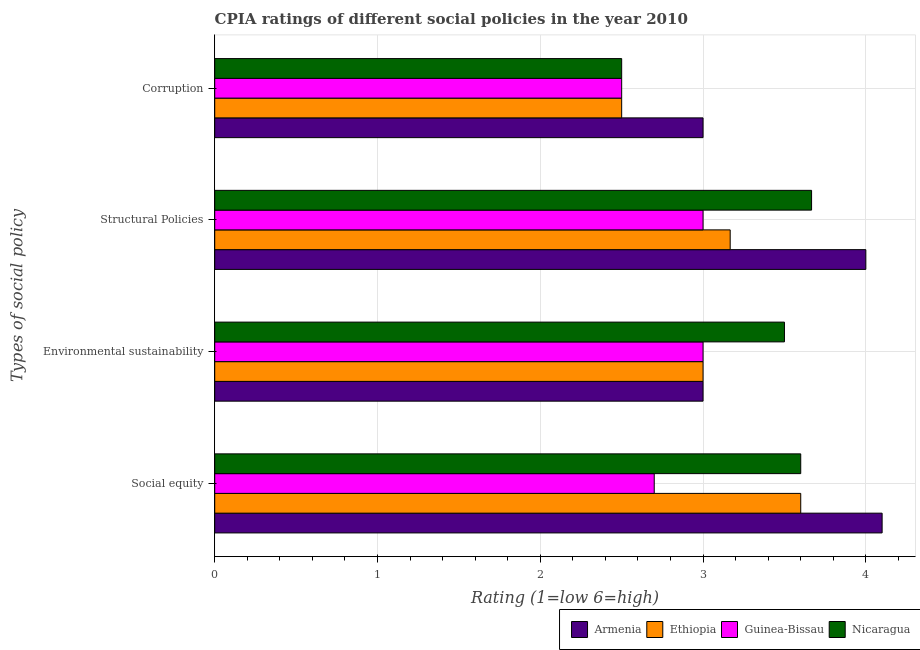Are the number of bars per tick equal to the number of legend labels?
Your answer should be very brief. Yes. Are the number of bars on each tick of the Y-axis equal?
Provide a succinct answer. Yes. How many bars are there on the 2nd tick from the bottom?
Your answer should be very brief. 4. What is the label of the 4th group of bars from the top?
Offer a very short reply. Social equity. In which country was the cpia rating of corruption maximum?
Your answer should be very brief. Armenia. In which country was the cpia rating of corruption minimum?
Provide a succinct answer. Ethiopia. What is the difference between the cpia rating of social equity in Guinea-Bissau and that in Armenia?
Provide a short and direct response. -1.4. What is the average cpia rating of environmental sustainability per country?
Keep it short and to the point. 3.12. What is the difference between the cpia rating of structural policies and cpia rating of environmental sustainability in Armenia?
Provide a short and direct response. 1. Is the cpia rating of corruption in Armenia less than that in Nicaragua?
Keep it short and to the point. No. Is the difference between the cpia rating of social equity in Guinea-Bissau and Ethiopia greater than the difference between the cpia rating of structural policies in Guinea-Bissau and Ethiopia?
Offer a terse response. No. What is the difference between the highest and the second highest cpia rating of social equity?
Your answer should be very brief. 0.5. What is the difference between the highest and the lowest cpia rating of environmental sustainability?
Your response must be concise. 0.5. Is it the case that in every country, the sum of the cpia rating of environmental sustainability and cpia rating of structural policies is greater than the sum of cpia rating of corruption and cpia rating of social equity?
Your response must be concise. No. What does the 1st bar from the top in Structural Policies represents?
Keep it short and to the point. Nicaragua. What does the 3rd bar from the bottom in Social equity represents?
Offer a terse response. Guinea-Bissau. How many bars are there?
Provide a succinct answer. 16. Are all the bars in the graph horizontal?
Provide a short and direct response. Yes. What is the difference between two consecutive major ticks on the X-axis?
Keep it short and to the point. 1. Where does the legend appear in the graph?
Offer a terse response. Bottom right. How many legend labels are there?
Your response must be concise. 4. What is the title of the graph?
Offer a very short reply. CPIA ratings of different social policies in the year 2010. What is the label or title of the X-axis?
Keep it short and to the point. Rating (1=low 6=high). What is the label or title of the Y-axis?
Provide a succinct answer. Types of social policy. What is the Rating (1=low 6=high) of Armenia in Social equity?
Provide a short and direct response. 4.1. What is the Rating (1=low 6=high) of Nicaragua in Social equity?
Ensure brevity in your answer.  3.6. What is the Rating (1=low 6=high) of Armenia in Environmental sustainability?
Provide a short and direct response. 3. What is the Rating (1=low 6=high) of Guinea-Bissau in Environmental sustainability?
Provide a short and direct response. 3. What is the Rating (1=low 6=high) of Nicaragua in Environmental sustainability?
Make the answer very short. 3.5. What is the Rating (1=low 6=high) in Armenia in Structural Policies?
Your answer should be compact. 4. What is the Rating (1=low 6=high) of Ethiopia in Structural Policies?
Provide a succinct answer. 3.17. What is the Rating (1=low 6=high) of Guinea-Bissau in Structural Policies?
Ensure brevity in your answer.  3. What is the Rating (1=low 6=high) of Nicaragua in Structural Policies?
Provide a short and direct response. 3.67. What is the Rating (1=low 6=high) of Armenia in Corruption?
Your answer should be very brief. 3. What is the Rating (1=low 6=high) of Ethiopia in Corruption?
Your answer should be very brief. 2.5. What is the Rating (1=low 6=high) of Nicaragua in Corruption?
Provide a succinct answer. 2.5. Across all Types of social policy, what is the maximum Rating (1=low 6=high) in Nicaragua?
Make the answer very short. 3.67. Across all Types of social policy, what is the minimum Rating (1=low 6=high) of Armenia?
Give a very brief answer. 3. Across all Types of social policy, what is the minimum Rating (1=low 6=high) of Ethiopia?
Your response must be concise. 2.5. Across all Types of social policy, what is the minimum Rating (1=low 6=high) of Guinea-Bissau?
Offer a very short reply. 2.5. What is the total Rating (1=low 6=high) in Armenia in the graph?
Offer a terse response. 14.1. What is the total Rating (1=low 6=high) in Ethiopia in the graph?
Provide a succinct answer. 12.27. What is the total Rating (1=low 6=high) of Nicaragua in the graph?
Offer a terse response. 13.27. What is the difference between the Rating (1=low 6=high) in Armenia in Social equity and that in Environmental sustainability?
Make the answer very short. 1.1. What is the difference between the Rating (1=low 6=high) of Ethiopia in Social equity and that in Environmental sustainability?
Make the answer very short. 0.6. What is the difference between the Rating (1=low 6=high) in Guinea-Bissau in Social equity and that in Environmental sustainability?
Ensure brevity in your answer.  -0.3. What is the difference between the Rating (1=low 6=high) in Armenia in Social equity and that in Structural Policies?
Provide a short and direct response. 0.1. What is the difference between the Rating (1=low 6=high) in Ethiopia in Social equity and that in Structural Policies?
Offer a terse response. 0.43. What is the difference between the Rating (1=low 6=high) of Nicaragua in Social equity and that in Structural Policies?
Offer a terse response. -0.07. What is the difference between the Rating (1=low 6=high) in Armenia in Social equity and that in Corruption?
Keep it short and to the point. 1.1. What is the difference between the Rating (1=low 6=high) in Ethiopia in Social equity and that in Corruption?
Offer a terse response. 1.1. What is the difference between the Rating (1=low 6=high) in Armenia in Environmental sustainability and that in Structural Policies?
Your answer should be compact. -1. What is the difference between the Rating (1=low 6=high) in Ethiopia in Environmental sustainability and that in Structural Policies?
Offer a terse response. -0.17. What is the difference between the Rating (1=low 6=high) of Armenia in Structural Policies and that in Corruption?
Offer a very short reply. 1. What is the difference between the Rating (1=low 6=high) in Guinea-Bissau in Structural Policies and that in Corruption?
Your answer should be compact. 0.5. What is the difference between the Rating (1=low 6=high) of Armenia in Social equity and the Rating (1=low 6=high) of Ethiopia in Environmental sustainability?
Make the answer very short. 1.1. What is the difference between the Rating (1=low 6=high) in Armenia in Social equity and the Rating (1=low 6=high) in Nicaragua in Environmental sustainability?
Make the answer very short. 0.6. What is the difference between the Rating (1=low 6=high) in Ethiopia in Social equity and the Rating (1=low 6=high) in Nicaragua in Environmental sustainability?
Keep it short and to the point. 0.1. What is the difference between the Rating (1=low 6=high) of Armenia in Social equity and the Rating (1=low 6=high) of Nicaragua in Structural Policies?
Your response must be concise. 0.43. What is the difference between the Rating (1=low 6=high) of Ethiopia in Social equity and the Rating (1=low 6=high) of Guinea-Bissau in Structural Policies?
Give a very brief answer. 0.6. What is the difference between the Rating (1=low 6=high) of Ethiopia in Social equity and the Rating (1=low 6=high) of Nicaragua in Structural Policies?
Your answer should be very brief. -0.07. What is the difference between the Rating (1=low 6=high) in Guinea-Bissau in Social equity and the Rating (1=low 6=high) in Nicaragua in Structural Policies?
Provide a short and direct response. -0.97. What is the difference between the Rating (1=low 6=high) in Armenia in Social equity and the Rating (1=low 6=high) in Ethiopia in Corruption?
Your answer should be compact. 1.6. What is the difference between the Rating (1=low 6=high) of Armenia in Social equity and the Rating (1=low 6=high) of Guinea-Bissau in Corruption?
Ensure brevity in your answer.  1.6. What is the difference between the Rating (1=low 6=high) in Ethiopia in Social equity and the Rating (1=low 6=high) in Guinea-Bissau in Corruption?
Provide a short and direct response. 1.1. What is the difference between the Rating (1=low 6=high) of Guinea-Bissau in Social equity and the Rating (1=low 6=high) of Nicaragua in Corruption?
Provide a short and direct response. 0.2. What is the difference between the Rating (1=low 6=high) of Armenia in Environmental sustainability and the Rating (1=low 6=high) of Ethiopia in Structural Policies?
Give a very brief answer. -0.17. What is the difference between the Rating (1=low 6=high) in Armenia in Environmental sustainability and the Rating (1=low 6=high) in Guinea-Bissau in Structural Policies?
Your answer should be compact. 0. What is the difference between the Rating (1=low 6=high) of Armenia in Environmental sustainability and the Rating (1=low 6=high) of Nicaragua in Structural Policies?
Keep it short and to the point. -0.67. What is the difference between the Rating (1=low 6=high) in Ethiopia in Environmental sustainability and the Rating (1=low 6=high) in Guinea-Bissau in Structural Policies?
Provide a succinct answer. 0. What is the difference between the Rating (1=low 6=high) in Ethiopia in Environmental sustainability and the Rating (1=low 6=high) in Nicaragua in Structural Policies?
Give a very brief answer. -0.67. What is the difference between the Rating (1=low 6=high) of Guinea-Bissau in Environmental sustainability and the Rating (1=low 6=high) of Nicaragua in Structural Policies?
Provide a succinct answer. -0.67. What is the difference between the Rating (1=low 6=high) in Armenia in Environmental sustainability and the Rating (1=low 6=high) in Ethiopia in Corruption?
Ensure brevity in your answer.  0.5. What is the difference between the Rating (1=low 6=high) in Armenia in Environmental sustainability and the Rating (1=low 6=high) in Guinea-Bissau in Corruption?
Make the answer very short. 0.5. What is the difference between the Rating (1=low 6=high) of Armenia in Structural Policies and the Rating (1=low 6=high) of Guinea-Bissau in Corruption?
Give a very brief answer. 1.5. What is the difference between the Rating (1=low 6=high) in Ethiopia in Structural Policies and the Rating (1=low 6=high) in Guinea-Bissau in Corruption?
Offer a very short reply. 0.67. What is the difference between the Rating (1=low 6=high) of Ethiopia in Structural Policies and the Rating (1=low 6=high) of Nicaragua in Corruption?
Provide a succinct answer. 0.67. What is the average Rating (1=low 6=high) of Armenia per Types of social policy?
Give a very brief answer. 3.52. What is the average Rating (1=low 6=high) in Ethiopia per Types of social policy?
Ensure brevity in your answer.  3.07. What is the average Rating (1=low 6=high) of Guinea-Bissau per Types of social policy?
Ensure brevity in your answer.  2.8. What is the average Rating (1=low 6=high) in Nicaragua per Types of social policy?
Provide a short and direct response. 3.32. What is the difference between the Rating (1=low 6=high) of Armenia and Rating (1=low 6=high) of Nicaragua in Social equity?
Offer a terse response. 0.5. What is the difference between the Rating (1=low 6=high) of Guinea-Bissau and Rating (1=low 6=high) of Nicaragua in Social equity?
Make the answer very short. -0.9. What is the difference between the Rating (1=low 6=high) in Armenia and Rating (1=low 6=high) in Ethiopia in Environmental sustainability?
Your answer should be very brief. 0. What is the difference between the Rating (1=low 6=high) in Armenia and Rating (1=low 6=high) in Guinea-Bissau in Environmental sustainability?
Offer a terse response. 0. What is the difference between the Rating (1=low 6=high) of Armenia and Rating (1=low 6=high) of Nicaragua in Environmental sustainability?
Keep it short and to the point. -0.5. What is the difference between the Rating (1=low 6=high) of Armenia and Rating (1=low 6=high) of Nicaragua in Structural Policies?
Make the answer very short. 0.33. What is the difference between the Rating (1=low 6=high) in Ethiopia and Rating (1=low 6=high) in Guinea-Bissau in Structural Policies?
Keep it short and to the point. 0.17. What is the difference between the Rating (1=low 6=high) in Armenia and Rating (1=low 6=high) in Ethiopia in Corruption?
Your answer should be compact. 0.5. What is the difference between the Rating (1=low 6=high) in Armenia and Rating (1=low 6=high) in Guinea-Bissau in Corruption?
Make the answer very short. 0.5. What is the difference between the Rating (1=low 6=high) of Armenia and Rating (1=low 6=high) of Nicaragua in Corruption?
Make the answer very short. 0.5. What is the difference between the Rating (1=low 6=high) of Ethiopia and Rating (1=low 6=high) of Guinea-Bissau in Corruption?
Your answer should be compact. 0. What is the ratio of the Rating (1=low 6=high) in Armenia in Social equity to that in Environmental sustainability?
Offer a very short reply. 1.37. What is the ratio of the Rating (1=low 6=high) of Ethiopia in Social equity to that in Environmental sustainability?
Offer a terse response. 1.2. What is the ratio of the Rating (1=low 6=high) in Nicaragua in Social equity to that in Environmental sustainability?
Offer a terse response. 1.03. What is the ratio of the Rating (1=low 6=high) of Ethiopia in Social equity to that in Structural Policies?
Make the answer very short. 1.14. What is the ratio of the Rating (1=low 6=high) in Nicaragua in Social equity to that in Structural Policies?
Your answer should be compact. 0.98. What is the ratio of the Rating (1=low 6=high) of Armenia in Social equity to that in Corruption?
Offer a very short reply. 1.37. What is the ratio of the Rating (1=low 6=high) in Ethiopia in Social equity to that in Corruption?
Keep it short and to the point. 1.44. What is the ratio of the Rating (1=low 6=high) of Nicaragua in Social equity to that in Corruption?
Offer a terse response. 1.44. What is the ratio of the Rating (1=low 6=high) in Armenia in Environmental sustainability to that in Structural Policies?
Your response must be concise. 0.75. What is the ratio of the Rating (1=low 6=high) of Ethiopia in Environmental sustainability to that in Structural Policies?
Your answer should be compact. 0.95. What is the ratio of the Rating (1=low 6=high) of Nicaragua in Environmental sustainability to that in Structural Policies?
Provide a succinct answer. 0.95. What is the ratio of the Rating (1=low 6=high) of Armenia in Environmental sustainability to that in Corruption?
Ensure brevity in your answer.  1. What is the ratio of the Rating (1=low 6=high) of Nicaragua in Environmental sustainability to that in Corruption?
Provide a short and direct response. 1.4. What is the ratio of the Rating (1=low 6=high) of Armenia in Structural Policies to that in Corruption?
Provide a succinct answer. 1.33. What is the ratio of the Rating (1=low 6=high) in Ethiopia in Structural Policies to that in Corruption?
Provide a short and direct response. 1.27. What is the ratio of the Rating (1=low 6=high) in Nicaragua in Structural Policies to that in Corruption?
Keep it short and to the point. 1.47. What is the difference between the highest and the second highest Rating (1=low 6=high) of Armenia?
Offer a very short reply. 0.1. What is the difference between the highest and the second highest Rating (1=low 6=high) of Ethiopia?
Your answer should be compact. 0.43. What is the difference between the highest and the second highest Rating (1=low 6=high) of Guinea-Bissau?
Your response must be concise. 0. What is the difference between the highest and the second highest Rating (1=low 6=high) in Nicaragua?
Your answer should be very brief. 0.07. What is the difference between the highest and the lowest Rating (1=low 6=high) in Armenia?
Provide a short and direct response. 1.1. What is the difference between the highest and the lowest Rating (1=low 6=high) of Ethiopia?
Give a very brief answer. 1.1. What is the difference between the highest and the lowest Rating (1=low 6=high) of Nicaragua?
Provide a succinct answer. 1.17. 